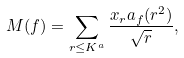<formula> <loc_0><loc_0><loc_500><loc_500>M ( f ) = \sum _ { r \leq K ^ { a } } \frac { x _ { r } a _ { f } ( r ^ { 2 } ) } { \sqrt { r } } ,</formula> 